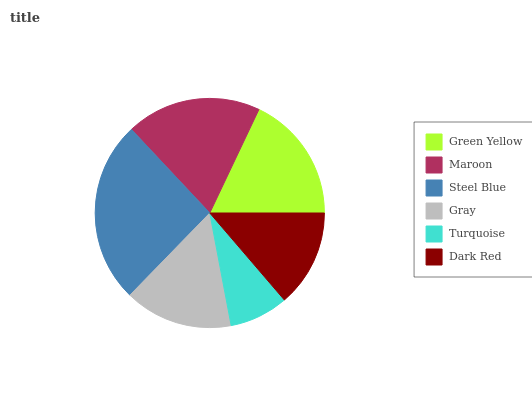Is Turquoise the minimum?
Answer yes or no. Yes. Is Steel Blue the maximum?
Answer yes or no. Yes. Is Maroon the minimum?
Answer yes or no. No. Is Maroon the maximum?
Answer yes or no. No. Is Maroon greater than Green Yellow?
Answer yes or no. Yes. Is Green Yellow less than Maroon?
Answer yes or no. Yes. Is Green Yellow greater than Maroon?
Answer yes or no. No. Is Maroon less than Green Yellow?
Answer yes or no. No. Is Green Yellow the high median?
Answer yes or no. Yes. Is Gray the low median?
Answer yes or no. Yes. Is Steel Blue the high median?
Answer yes or no. No. Is Steel Blue the low median?
Answer yes or no. No. 